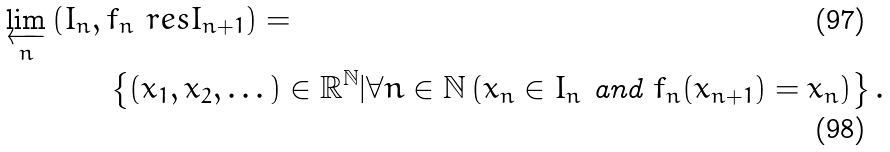Convert formula to latex. <formula><loc_0><loc_0><loc_500><loc_500>\varprojlim _ { n } \, ( I _ { n } , \, & f _ { n } \ r e s I _ { n + 1 } ) = \\ & \left \{ ( x _ { 1 } , x _ { 2 } , \dots ) \in \mathbb { R } ^ { \mathbb { N } } | \forall n \in \mathbb { N } \left ( x _ { n } \in I _ { n } \text { and } f _ { n } ( x _ { n + 1 } ) = x _ { n } \right ) \right \} .</formula> 